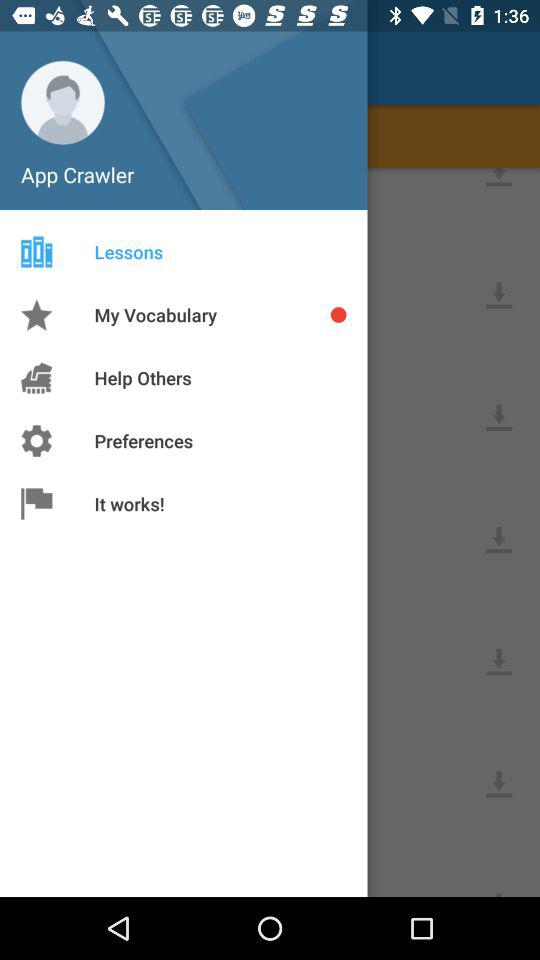What is the user name? The user name is App Crawler. 